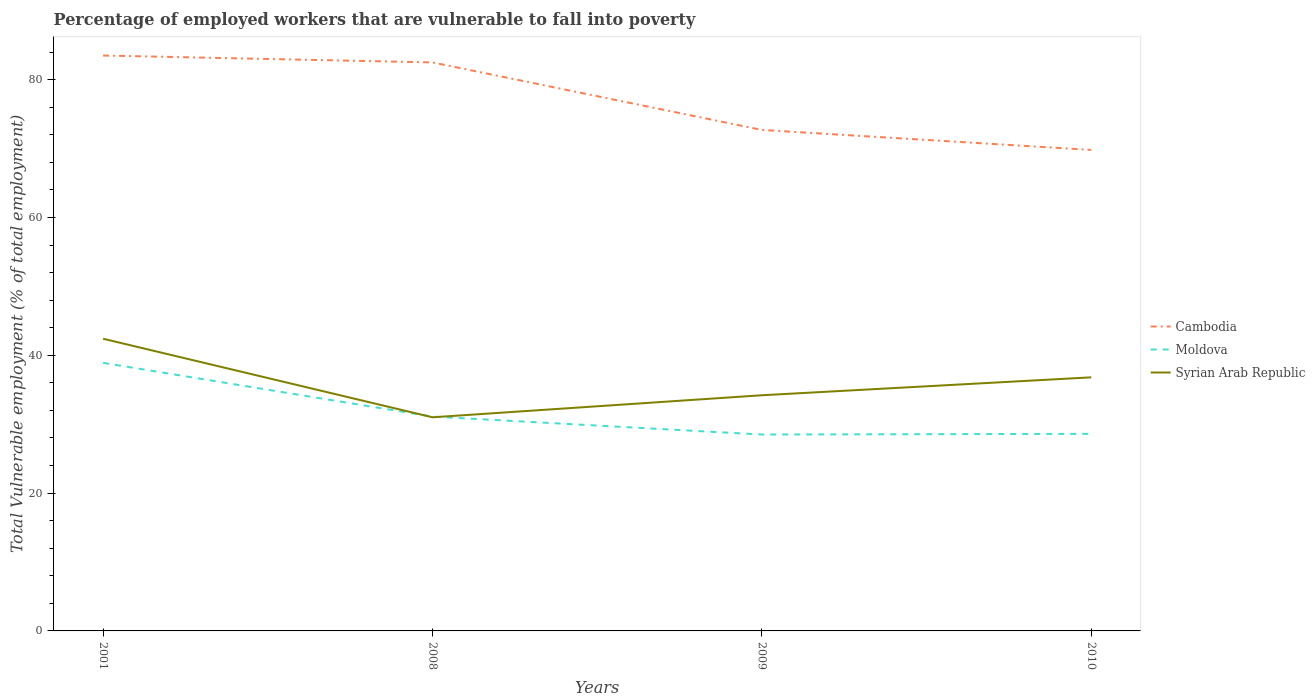How many different coloured lines are there?
Ensure brevity in your answer.  3. Is the number of lines equal to the number of legend labels?
Make the answer very short. Yes. Across all years, what is the maximum percentage of employed workers who are vulnerable to fall into poverty in Cambodia?
Provide a short and direct response. 69.8. What is the total percentage of employed workers who are vulnerable to fall into poverty in Cambodia in the graph?
Your answer should be very brief. 9.8. What is the difference between the highest and the second highest percentage of employed workers who are vulnerable to fall into poverty in Cambodia?
Make the answer very short. 13.7. What is the difference between the highest and the lowest percentage of employed workers who are vulnerable to fall into poverty in Cambodia?
Your response must be concise. 2. Is the percentage of employed workers who are vulnerable to fall into poverty in Syrian Arab Republic strictly greater than the percentage of employed workers who are vulnerable to fall into poverty in Moldova over the years?
Make the answer very short. No. How many lines are there?
Provide a succinct answer. 3. Are the values on the major ticks of Y-axis written in scientific E-notation?
Ensure brevity in your answer.  No. Does the graph contain grids?
Provide a short and direct response. No. Where does the legend appear in the graph?
Offer a very short reply. Center right. How are the legend labels stacked?
Offer a terse response. Vertical. What is the title of the graph?
Your answer should be very brief. Percentage of employed workers that are vulnerable to fall into poverty. What is the label or title of the Y-axis?
Ensure brevity in your answer.  Total Vulnerable employment (% of total employment). What is the Total Vulnerable employment (% of total employment) in Cambodia in 2001?
Make the answer very short. 83.5. What is the Total Vulnerable employment (% of total employment) of Moldova in 2001?
Keep it short and to the point. 38.9. What is the Total Vulnerable employment (% of total employment) of Syrian Arab Republic in 2001?
Provide a succinct answer. 42.4. What is the Total Vulnerable employment (% of total employment) in Cambodia in 2008?
Provide a short and direct response. 82.5. What is the Total Vulnerable employment (% of total employment) in Moldova in 2008?
Your answer should be compact. 31.1. What is the Total Vulnerable employment (% of total employment) of Syrian Arab Republic in 2008?
Ensure brevity in your answer.  31. What is the Total Vulnerable employment (% of total employment) in Cambodia in 2009?
Ensure brevity in your answer.  72.7. What is the Total Vulnerable employment (% of total employment) of Moldova in 2009?
Your answer should be compact. 28.5. What is the Total Vulnerable employment (% of total employment) in Syrian Arab Republic in 2009?
Offer a terse response. 34.2. What is the Total Vulnerable employment (% of total employment) of Cambodia in 2010?
Provide a succinct answer. 69.8. What is the Total Vulnerable employment (% of total employment) in Moldova in 2010?
Your response must be concise. 28.6. What is the Total Vulnerable employment (% of total employment) in Syrian Arab Republic in 2010?
Your answer should be compact. 36.8. Across all years, what is the maximum Total Vulnerable employment (% of total employment) of Cambodia?
Provide a succinct answer. 83.5. Across all years, what is the maximum Total Vulnerable employment (% of total employment) of Moldova?
Your response must be concise. 38.9. Across all years, what is the maximum Total Vulnerable employment (% of total employment) of Syrian Arab Republic?
Your response must be concise. 42.4. Across all years, what is the minimum Total Vulnerable employment (% of total employment) in Cambodia?
Make the answer very short. 69.8. Across all years, what is the minimum Total Vulnerable employment (% of total employment) of Moldova?
Give a very brief answer. 28.5. Across all years, what is the minimum Total Vulnerable employment (% of total employment) of Syrian Arab Republic?
Keep it short and to the point. 31. What is the total Total Vulnerable employment (% of total employment) in Cambodia in the graph?
Ensure brevity in your answer.  308.5. What is the total Total Vulnerable employment (% of total employment) of Moldova in the graph?
Make the answer very short. 127.1. What is the total Total Vulnerable employment (% of total employment) in Syrian Arab Republic in the graph?
Your response must be concise. 144.4. What is the difference between the Total Vulnerable employment (% of total employment) of Cambodia in 2001 and that in 2008?
Offer a terse response. 1. What is the difference between the Total Vulnerable employment (% of total employment) in Moldova in 2001 and that in 2008?
Offer a terse response. 7.8. What is the difference between the Total Vulnerable employment (% of total employment) of Syrian Arab Republic in 2001 and that in 2008?
Provide a succinct answer. 11.4. What is the difference between the Total Vulnerable employment (% of total employment) in Cambodia in 2001 and that in 2009?
Your answer should be compact. 10.8. What is the difference between the Total Vulnerable employment (% of total employment) of Moldova in 2001 and that in 2009?
Your response must be concise. 10.4. What is the difference between the Total Vulnerable employment (% of total employment) of Cambodia in 2008 and that in 2009?
Provide a short and direct response. 9.8. What is the difference between the Total Vulnerable employment (% of total employment) in Moldova in 2008 and that in 2009?
Your response must be concise. 2.6. What is the difference between the Total Vulnerable employment (% of total employment) of Syrian Arab Republic in 2008 and that in 2009?
Offer a very short reply. -3.2. What is the difference between the Total Vulnerable employment (% of total employment) of Cambodia in 2008 and that in 2010?
Offer a very short reply. 12.7. What is the difference between the Total Vulnerable employment (% of total employment) in Syrian Arab Republic in 2008 and that in 2010?
Make the answer very short. -5.8. What is the difference between the Total Vulnerable employment (% of total employment) in Moldova in 2009 and that in 2010?
Your response must be concise. -0.1. What is the difference between the Total Vulnerable employment (% of total employment) of Syrian Arab Republic in 2009 and that in 2010?
Offer a very short reply. -2.6. What is the difference between the Total Vulnerable employment (% of total employment) of Cambodia in 2001 and the Total Vulnerable employment (% of total employment) of Moldova in 2008?
Provide a short and direct response. 52.4. What is the difference between the Total Vulnerable employment (% of total employment) of Cambodia in 2001 and the Total Vulnerable employment (% of total employment) of Syrian Arab Republic in 2008?
Your answer should be very brief. 52.5. What is the difference between the Total Vulnerable employment (% of total employment) in Moldova in 2001 and the Total Vulnerable employment (% of total employment) in Syrian Arab Republic in 2008?
Your response must be concise. 7.9. What is the difference between the Total Vulnerable employment (% of total employment) in Cambodia in 2001 and the Total Vulnerable employment (% of total employment) in Moldova in 2009?
Give a very brief answer. 55. What is the difference between the Total Vulnerable employment (% of total employment) in Cambodia in 2001 and the Total Vulnerable employment (% of total employment) in Syrian Arab Republic in 2009?
Provide a succinct answer. 49.3. What is the difference between the Total Vulnerable employment (% of total employment) of Moldova in 2001 and the Total Vulnerable employment (% of total employment) of Syrian Arab Republic in 2009?
Provide a short and direct response. 4.7. What is the difference between the Total Vulnerable employment (% of total employment) of Cambodia in 2001 and the Total Vulnerable employment (% of total employment) of Moldova in 2010?
Your answer should be compact. 54.9. What is the difference between the Total Vulnerable employment (% of total employment) of Cambodia in 2001 and the Total Vulnerable employment (% of total employment) of Syrian Arab Republic in 2010?
Make the answer very short. 46.7. What is the difference between the Total Vulnerable employment (% of total employment) of Cambodia in 2008 and the Total Vulnerable employment (% of total employment) of Moldova in 2009?
Make the answer very short. 54. What is the difference between the Total Vulnerable employment (% of total employment) of Cambodia in 2008 and the Total Vulnerable employment (% of total employment) of Syrian Arab Republic in 2009?
Keep it short and to the point. 48.3. What is the difference between the Total Vulnerable employment (% of total employment) in Moldova in 2008 and the Total Vulnerable employment (% of total employment) in Syrian Arab Republic in 2009?
Your response must be concise. -3.1. What is the difference between the Total Vulnerable employment (% of total employment) in Cambodia in 2008 and the Total Vulnerable employment (% of total employment) in Moldova in 2010?
Make the answer very short. 53.9. What is the difference between the Total Vulnerable employment (% of total employment) of Cambodia in 2008 and the Total Vulnerable employment (% of total employment) of Syrian Arab Republic in 2010?
Make the answer very short. 45.7. What is the difference between the Total Vulnerable employment (% of total employment) of Cambodia in 2009 and the Total Vulnerable employment (% of total employment) of Moldova in 2010?
Offer a terse response. 44.1. What is the difference between the Total Vulnerable employment (% of total employment) of Cambodia in 2009 and the Total Vulnerable employment (% of total employment) of Syrian Arab Republic in 2010?
Ensure brevity in your answer.  35.9. What is the difference between the Total Vulnerable employment (% of total employment) of Moldova in 2009 and the Total Vulnerable employment (% of total employment) of Syrian Arab Republic in 2010?
Ensure brevity in your answer.  -8.3. What is the average Total Vulnerable employment (% of total employment) in Cambodia per year?
Keep it short and to the point. 77.12. What is the average Total Vulnerable employment (% of total employment) of Moldova per year?
Your response must be concise. 31.77. What is the average Total Vulnerable employment (% of total employment) in Syrian Arab Republic per year?
Your response must be concise. 36.1. In the year 2001, what is the difference between the Total Vulnerable employment (% of total employment) in Cambodia and Total Vulnerable employment (% of total employment) in Moldova?
Give a very brief answer. 44.6. In the year 2001, what is the difference between the Total Vulnerable employment (% of total employment) of Cambodia and Total Vulnerable employment (% of total employment) of Syrian Arab Republic?
Make the answer very short. 41.1. In the year 2001, what is the difference between the Total Vulnerable employment (% of total employment) of Moldova and Total Vulnerable employment (% of total employment) of Syrian Arab Republic?
Keep it short and to the point. -3.5. In the year 2008, what is the difference between the Total Vulnerable employment (% of total employment) of Cambodia and Total Vulnerable employment (% of total employment) of Moldova?
Keep it short and to the point. 51.4. In the year 2008, what is the difference between the Total Vulnerable employment (% of total employment) in Cambodia and Total Vulnerable employment (% of total employment) in Syrian Arab Republic?
Offer a terse response. 51.5. In the year 2008, what is the difference between the Total Vulnerable employment (% of total employment) of Moldova and Total Vulnerable employment (% of total employment) of Syrian Arab Republic?
Your response must be concise. 0.1. In the year 2009, what is the difference between the Total Vulnerable employment (% of total employment) in Cambodia and Total Vulnerable employment (% of total employment) in Moldova?
Your response must be concise. 44.2. In the year 2009, what is the difference between the Total Vulnerable employment (% of total employment) in Cambodia and Total Vulnerable employment (% of total employment) in Syrian Arab Republic?
Keep it short and to the point. 38.5. In the year 2009, what is the difference between the Total Vulnerable employment (% of total employment) of Moldova and Total Vulnerable employment (% of total employment) of Syrian Arab Republic?
Make the answer very short. -5.7. In the year 2010, what is the difference between the Total Vulnerable employment (% of total employment) in Cambodia and Total Vulnerable employment (% of total employment) in Moldova?
Your answer should be compact. 41.2. What is the ratio of the Total Vulnerable employment (% of total employment) of Cambodia in 2001 to that in 2008?
Ensure brevity in your answer.  1.01. What is the ratio of the Total Vulnerable employment (% of total employment) in Moldova in 2001 to that in 2008?
Your response must be concise. 1.25. What is the ratio of the Total Vulnerable employment (% of total employment) of Syrian Arab Republic in 2001 to that in 2008?
Provide a short and direct response. 1.37. What is the ratio of the Total Vulnerable employment (% of total employment) of Cambodia in 2001 to that in 2009?
Keep it short and to the point. 1.15. What is the ratio of the Total Vulnerable employment (% of total employment) in Moldova in 2001 to that in 2009?
Ensure brevity in your answer.  1.36. What is the ratio of the Total Vulnerable employment (% of total employment) of Syrian Arab Republic in 2001 to that in 2009?
Give a very brief answer. 1.24. What is the ratio of the Total Vulnerable employment (% of total employment) in Cambodia in 2001 to that in 2010?
Your response must be concise. 1.2. What is the ratio of the Total Vulnerable employment (% of total employment) of Moldova in 2001 to that in 2010?
Offer a very short reply. 1.36. What is the ratio of the Total Vulnerable employment (% of total employment) of Syrian Arab Republic in 2001 to that in 2010?
Give a very brief answer. 1.15. What is the ratio of the Total Vulnerable employment (% of total employment) in Cambodia in 2008 to that in 2009?
Ensure brevity in your answer.  1.13. What is the ratio of the Total Vulnerable employment (% of total employment) of Moldova in 2008 to that in 2009?
Your answer should be very brief. 1.09. What is the ratio of the Total Vulnerable employment (% of total employment) of Syrian Arab Republic in 2008 to that in 2009?
Provide a succinct answer. 0.91. What is the ratio of the Total Vulnerable employment (% of total employment) of Cambodia in 2008 to that in 2010?
Give a very brief answer. 1.18. What is the ratio of the Total Vulnerable employment (% of total employment) in Moldova in 2008 to that in 2010?
Keep it short and to the point. 1.09. What is the ratio of the Total Vulnerable employment (% of total employment) in Syrian Arab Republic in 2008 to that in 2010?
Give a very brief answer. 0.84. What is the ratio of the Total Vulnerable employment (% of total employment) in Cambodia in 2009 to that in 2010?
Provide a short and direct response. 1.04. What is the ratio of the Total Vulnerable employment (% of total employment) of Moldova in 2009 to that in 2010?
Your answer should be compact. 1. What is the ratio of the Total Vulnerable employment (% of total employment) of Syrian Arab Republic in 2009 to that in 2010?
Give a very brief answer. 0.93. What is the difference between the highest and the second highest Total Vulnerable employment (% of total employment) of Syrian Arab Republic?
Offer a terse response. 5.6. What is the difference between the highest and the lowest Total Vulnerable employment (% of total employment) in Cambodia?
Your response must be concise. 13.7. What is the difference between the highest and the lowest Total Vulnerable employment (% of total employment) of Moldova?
Give a very brief answer. 10.4. 